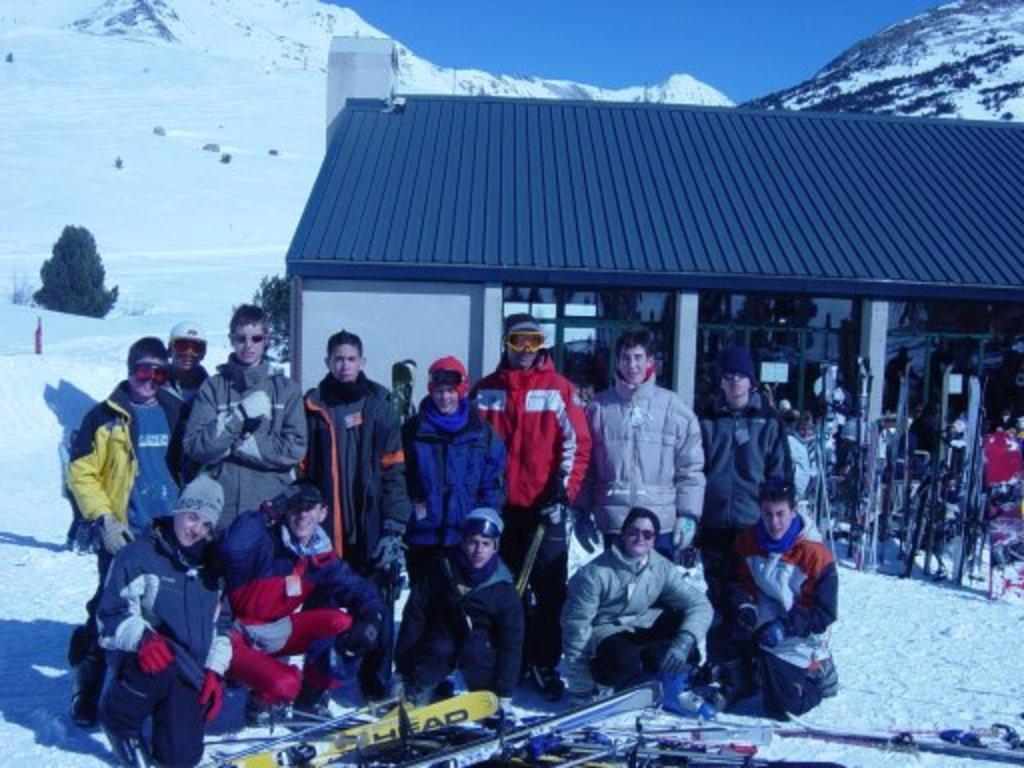Can you describe this image briefly? In this picture we can see a group people, here we can see snow, shed, skis and some objects and in the background we can see trees, mountains, sky 